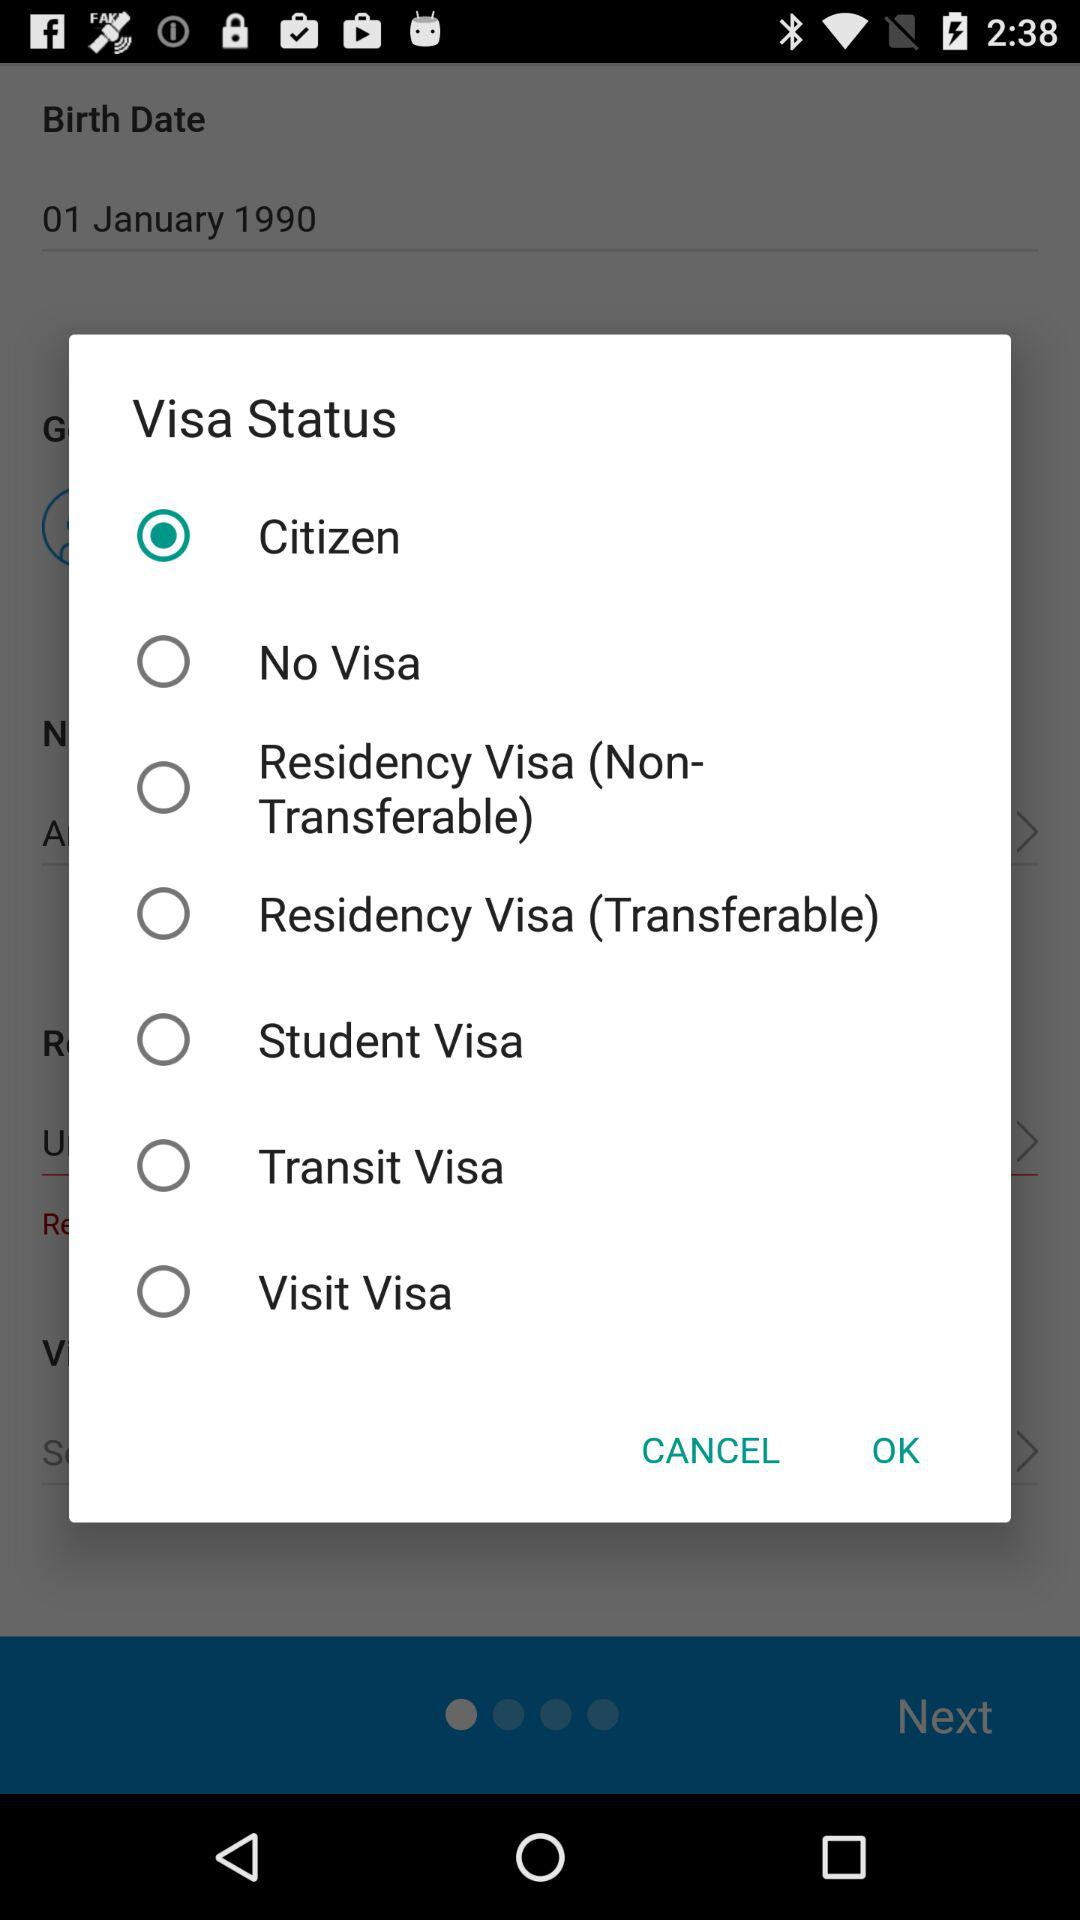Which option has been selected in "Visa Status"? The option that has been selected is "Citizen". 